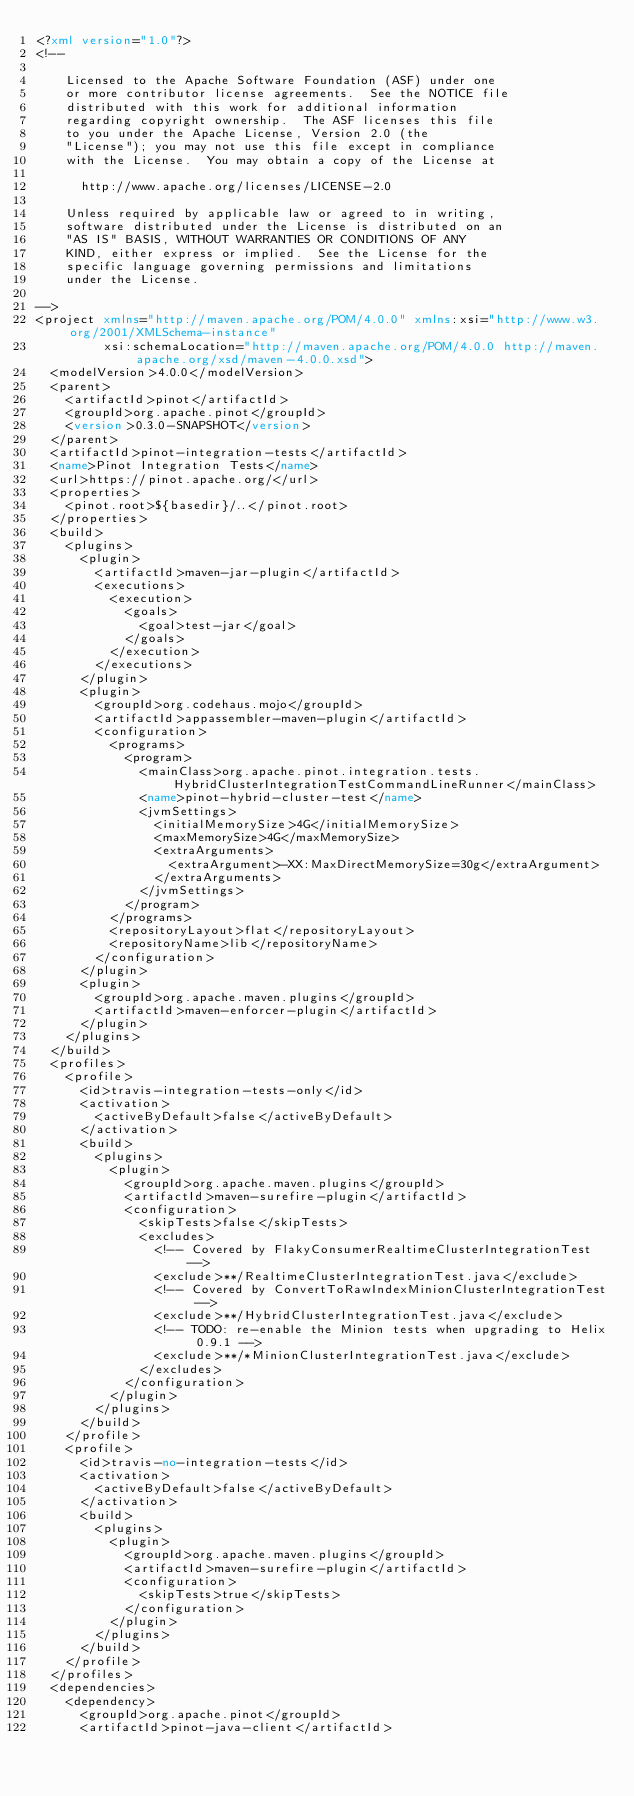<code> <loc_0><loc_0><loc_500><loc_500><_XML_><?xml version="1.0"?>
<!--

    Licensed to the Apache Software Foundation (ASF) under one
    or more contributor license agreements.  See the NOTICE file
    distributed with this work for additional information
    regarding copyright ownership.  The ASF licenses this file
    to you under the Apache License, Version 2.0 (the
    "License"); you may not use this file except in compliance
    with the License.  You may obtain a copy of the License at

      http://www.apache.org/licenses/LICENSE-2.0

    Unless required by applicable law or agreed to in writing,
    software distributed under the License is distributed on an
    "AS IS" BASIS, WITHOUT WARRANTIES OR CONDITIONS OF ANY
    KIND, either express or implied.  See the License for the
    specific language governing permissions and limitations
    under the License.

-->
<project xmlns="http://maven.apache.org/POM/4.0.0" xmlns:xsi="http://www.w3.org/2001/XMLSchema-instance"
         xsi:schemaLocation="http://maven.apache.org/POM/4.0.0 http://maven.apache.org/xsd/maven-4.0.0.xsd">
  <modelVersion>4.0.0</modelVersion>
  <parent>
    <artifactId>pinot</artifactId>
    <groupId>org.apache.pinot</groupId>
    <version>0.3.0-SNAPSHOT</version>
  </parent>
  <artifactId>pinot-integration-tests</artifactId>
  <name>Pinot Integration Tests</name>
  <url>https://pinot.apache.org/</url>
  <properties>
    <pinot.root>${basedir}/..</pinot.root>
  </properties>
  <build>
    <plugins>
      <plugin>
        <artifactId>maven-jar-plugin</artifactId>
        <executions>
          <execution>
            <goals>
              <goal>test-jar</goal>
            </goals>
          </execution>
        </executions>
      </plugin>
      <plugin>
        <groupId>org.codehaus.mojo</groupId>
        <artifactId>appassembler-maven-plugin</artifactId>
        <configuration>
          <programs>
            <program>
              <mainClass>org.apache.pinot.integration.tests.HybridClusterIntegrationTestCommandLineRunner</mainClass>
              <name>pinot-hybrid-cluster-test</name>
              <jvmSettings>
                <initialMemorySize>4G</initialMemorySize>
                <maxMemorySize>4G</maxMemorySize>
                <extraArguments>
                  <extraArgument>-XX:MaxDirectMemorySize=30g</extraArgument>
                </extraArguments>
              </jvmSettings>
            </program>
          </programs>
          <repositoryLayout>flat</repositoryLayout>
          <repositoryName>lib</repositoryName>
        </configuration>
      </plugin>
      <plugin>
        <groupId>org.apache.maven.plugins</groupId>
        <artifactId>maven-enforcer-plugin</artifactId>
      </plugin>
    </plugins>
  </build>
  <profiles>
    <profile>
      <id>travis-integration-tests-only</id>
      <activation>
        <activeByDefault>false</activeByDefault>
      </activation>
      <build>
        <plugins>
          <plugin>
            <groupId>org.apache.maven.plugins</groupId>
            <artifactId>maven-surefire-plugin</artifactId>
            <configuration>
              <skipTests>false</skipTests>
              <excludes>
                <!-- Covered by FlakyConsumerRealtimeClusterIntegrationTest -->
                <exclude>**/RealtimeClusterIntegrationTest.java</exclude>
                <!-- Covered by ConvertToRawIndexMinionClusterIntegrationTest -->
                <exclude>**/HybridClusterIntegrationTest.java</exclude>
                <!-- TODO: re-enable the Minion tests when upgrading to Helix 0.9.1 -->
                <exclude>**/*MinionClusterIntegrationTest.java</exclude>
              </excludes>
            </configuration>
          </plugin>
        </plugins>
      </build>
    </profile>
    <profile>
      <id>travis-no-integration-tests</id>
      <activation>
        <activeByDefault>false</activeByDefault>
      </activation>
      <build>
        <plugins>
          <plugin>
            <groupId>org.apache.maven.plugins</groupId>
            <artifactId>maven-surefire-plugin</artifactId>
            <configuration>
              <skipTests>true</skipTests>
            </configuration>
          </plugin>
        </plugins>
      </build>
    </profile>
  </profiles>
  <dependencies>
    <dependency>
      <groupId>org.apache.pinot</groupId>
      <artifactId>pinot-java-client</artifactId></code> 